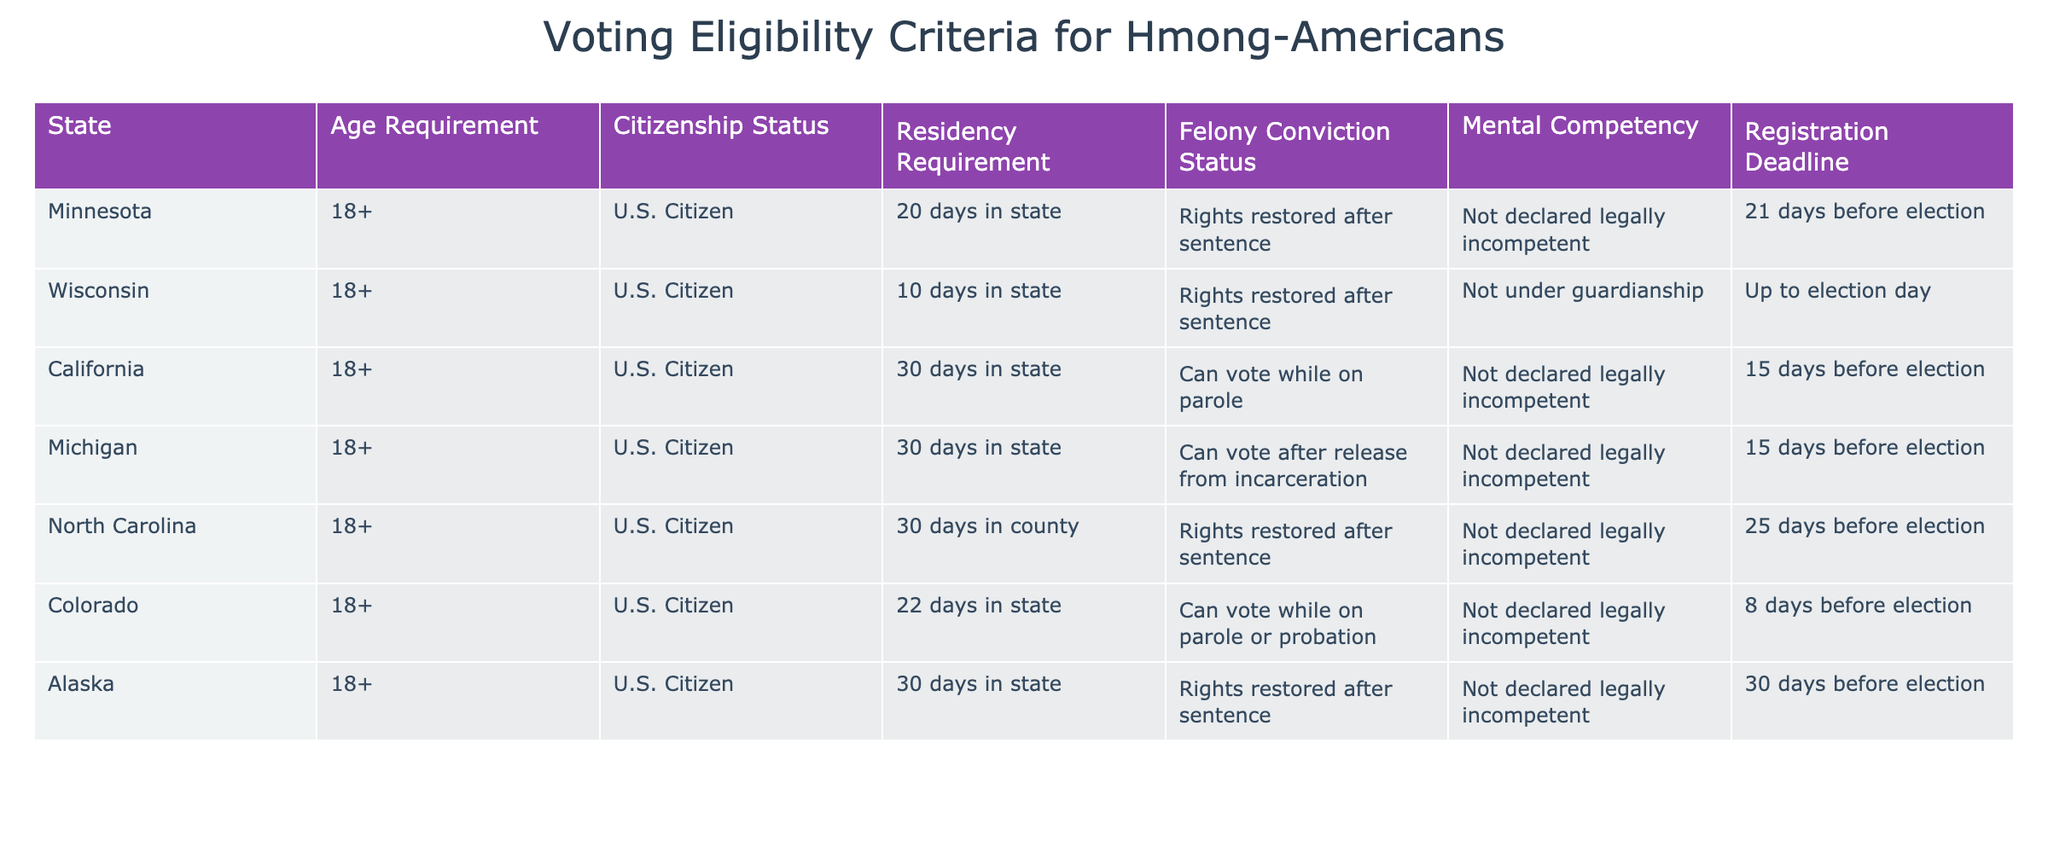What is the registration deadline for voting in Minnesota? According to the table, the registration deadline for Minnesota is 21 days before the election.
Answer: 21 days before election Which state allows voting for individuals who are on parole? The table shows that California and Colorado permit individuals on parole to vote.
Answer: California and Colorado What is the age requirement to vote in all the states listed? The table indicates that the age requirement across all listed states is 18 years and older.
Answer: 18 years and older Which state has the shortest residency requirement for voting? By comparing the residency requirements, Colorado has the shortest requirement at 22 days in the state.
Answer: 22 days in state Is it true that mental competency is a requirement for voting eligibility in Michigan? The table shows that in Michigan, individuals are not declared legally incompetent to vote, so mental competency must not be a barrier to eligibility.
Answer: Yes Which states have a residency requirement of 30 days or more? The table lists California, Michigan, North Carolina, Alaska, and has a residency requirement of 30 days in state.
Answer: California, Michigan, North Carolina, Alaska If a Hmong-American has a felony conviction, in which states can they still vote? The table indicates that individuals with felony convictions can vote while on parole in California and Colorado and after release from incarceration in Michigan.
Answer: California, Colorado, Michigan What is the average registration deadline across all the states listed? The registration deadlines are 21, up to election day (considered as 0), 15, 15, 25, 8, and 30 days. Adding these gives 115 days. Dividing by 7 (the number of states) gives an average of approximately 16.43 days.
Answer: 16.43 days Are there any states where residency does not apply for voting eligibility? The table specifies residency requirements for all states listed, indicating that there are no states without such requirements.
Answer: No 